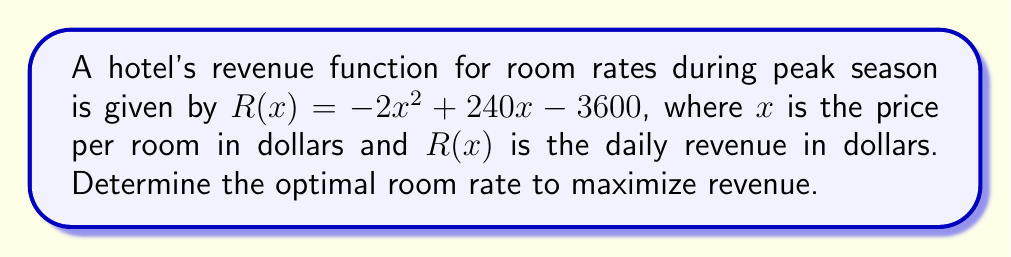Give your solution to this math problem. To find the optimal room rate that maximizes revenue, we need to find the maximum point of the revenue function. This can be done by following these steps:

1. Find the derivative of the revenue function:
   $$R'(x) = -4x + 240$$

2. Set the derivative equal to zero to find the critical point:
   $$-4x + 240 = 0$$
   $$-4x = -240$$
   $$x = 60$$

3. Verify that this critical point is a maximum by checking the second derivative:
   $$R''(x) = -4$$
   Since $R''(x)$ is negative, the critical point is indeed a maximum.

4. Therefore, the optimal room rate to maximize revenue is $60 per night.

5. We can calculate the maximum revenue by plugging $x = 60$ into the original revenue function:
   $$R(60) = -2(60)^2 + 240(60) - 3600$$
   $$= -7200 + 14400 - 3600$$
   $$= 3600$$

Thus, the maximum daily revenue is $3600 when the room rate is set at $60 per night.
Answer: $60 per night 